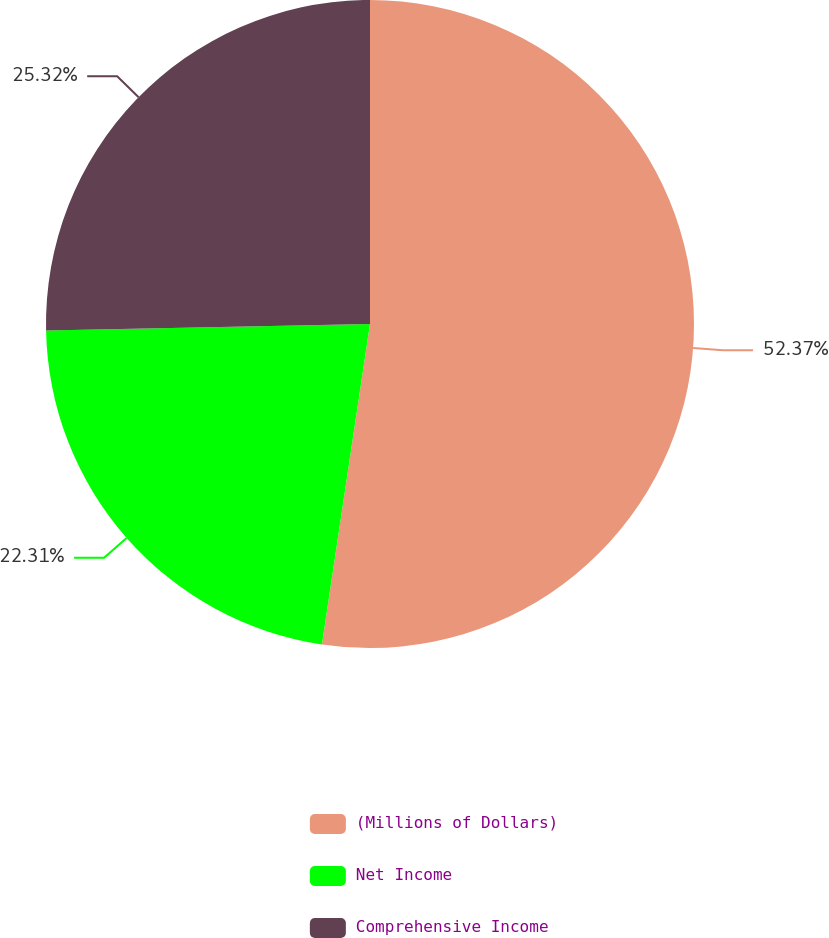<chart> <loc_0><loc_0><loc_500><loc_500><pie_chart><fcel>(Millions of Dollars)<fcel>Net Income<fcel>Comprehensive Income<nl><fcel>52.37%<fcel>22.31%<fcel>25.32%<nl></chart> 